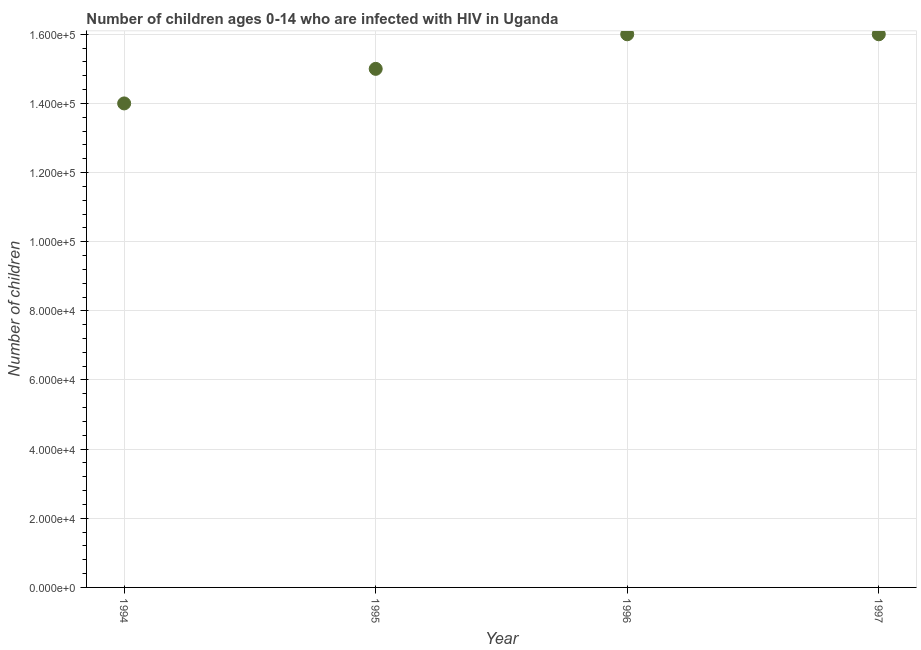What is the number of children living with hiv in 1996?
Ensure brevity in your answer.  1.60e+05. Across all years, what is the maximum number of children living with hiv?
Keep it short and to the point. 1.60e+05. Across all years, what is the minimum number of children living with hiv?
Ensure brevity in your answer.  1.40e+05. In which year was the number of children living with hiv minimum?
Offer a very short reply. 1994. What is the sum of the number of children living with hiv?
Give a very brief answer. 6.10e+05. What is the difference between the number of children living with hiv in 1995 and 1996?
Your response must be concise. -10000. What is the average number of children living with hiv per year?
Your answer should be very brief. 1.52e+05. What is the median number of children living with hiv?
Provide a succinct answer. 1.55e+05. In how many years, is the number of children living with hiv greater than 8000 ?
Offer a very short reply. 4. Is the difference between the number of children living with hiv in 1994 and 1996 greater than the difference between any two years?
Keep it short and to the point. Yes. What is the difference between the highest and the lowest number of children living with hiv?
Offer a very short reply. 2.00e+04. Does the number of children living with hiv monotonically increase over the years?
Make the answer very short. No. How many dotlines are there?
Provide a succinct answer. 1. How many years are there in the graph?
Your response must be concise. 4. Are the values on the major ticks of Y-axis written in scientific E-notation?
Your answer should be compact. Yes. Does the graph contain grids?
Your response must be concise. Yes. What is the title of the graph?
Your answer should be compact. Number of children ages 0-14 who are infected with HIV in Uganda. What is the label or title of the Y-axis?
Your answer should be compact. Number of children. What is the Number of children in 1994?
Keep it short and to the point. 1.40e+05. What is the Number of children in 1997?
Offer a very short reply. 1.60e+05. What is the difference between the Number of children in 1996 and 1997?
Provide a succinct answer. 0. What is the ratio of the Number of children in 1994 to that in 1995?
Your response must be concise. 0.93. What is the ratio of the Number of children in 1994 to that in 1997?
Offer a terse response. 0.88. What is the ratio of the Number of children in 1995 to that in 1996?
Keep it short and to the point. 0.94. What is the ratio of the Number of children in 1995 to that in 1997?
Offer a very short reply. 0.94. 